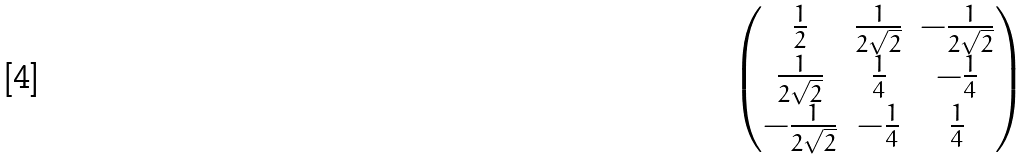<formula> <loc_0><loc_0><loc_500><loc_500>\begin{pmatrix} \frac { 1 } { 2 } & \frac { 1 } { 2 \sqrt { 2 } } & - \frac { 1 } { 2 \sqrt { 2 } } \\ \frac { 1 } { 2 \sqrt { 2 } } & \frac { 1 } { 4 } & - \frac { 1 } { 4 } \\ - \frac { 1 } { 2 \sqrt { 2 } } & - \frac { 1 } { 4 } & \frac { 1 } { 4 } \end{pmatrix}</formula> 